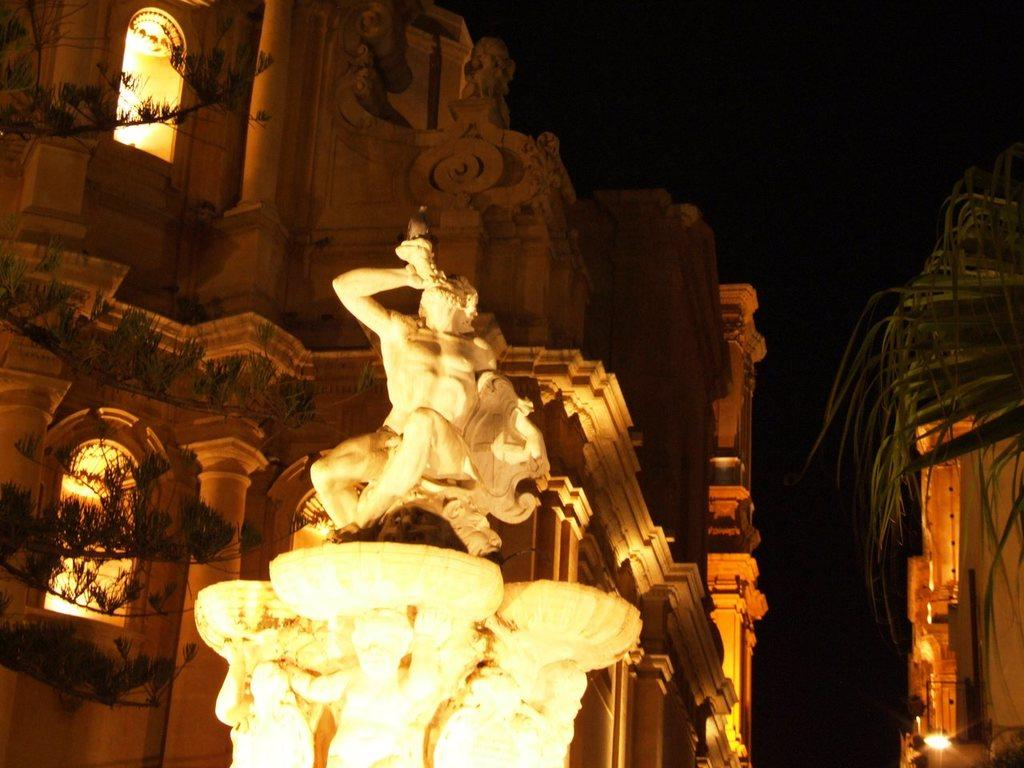What is the main subject in the foreground of the image? There is a sculpture in the foreground of the image. What can be seen in the background of the image? There are buildings and plants in the background of the image. Are there any artificial light sources visible in the image? Yes, there are lights visible in the image. What type of quilt is draped over the sculpture in the image? There is no quilt present in the image; the sculpture is not covered by any fabric. 